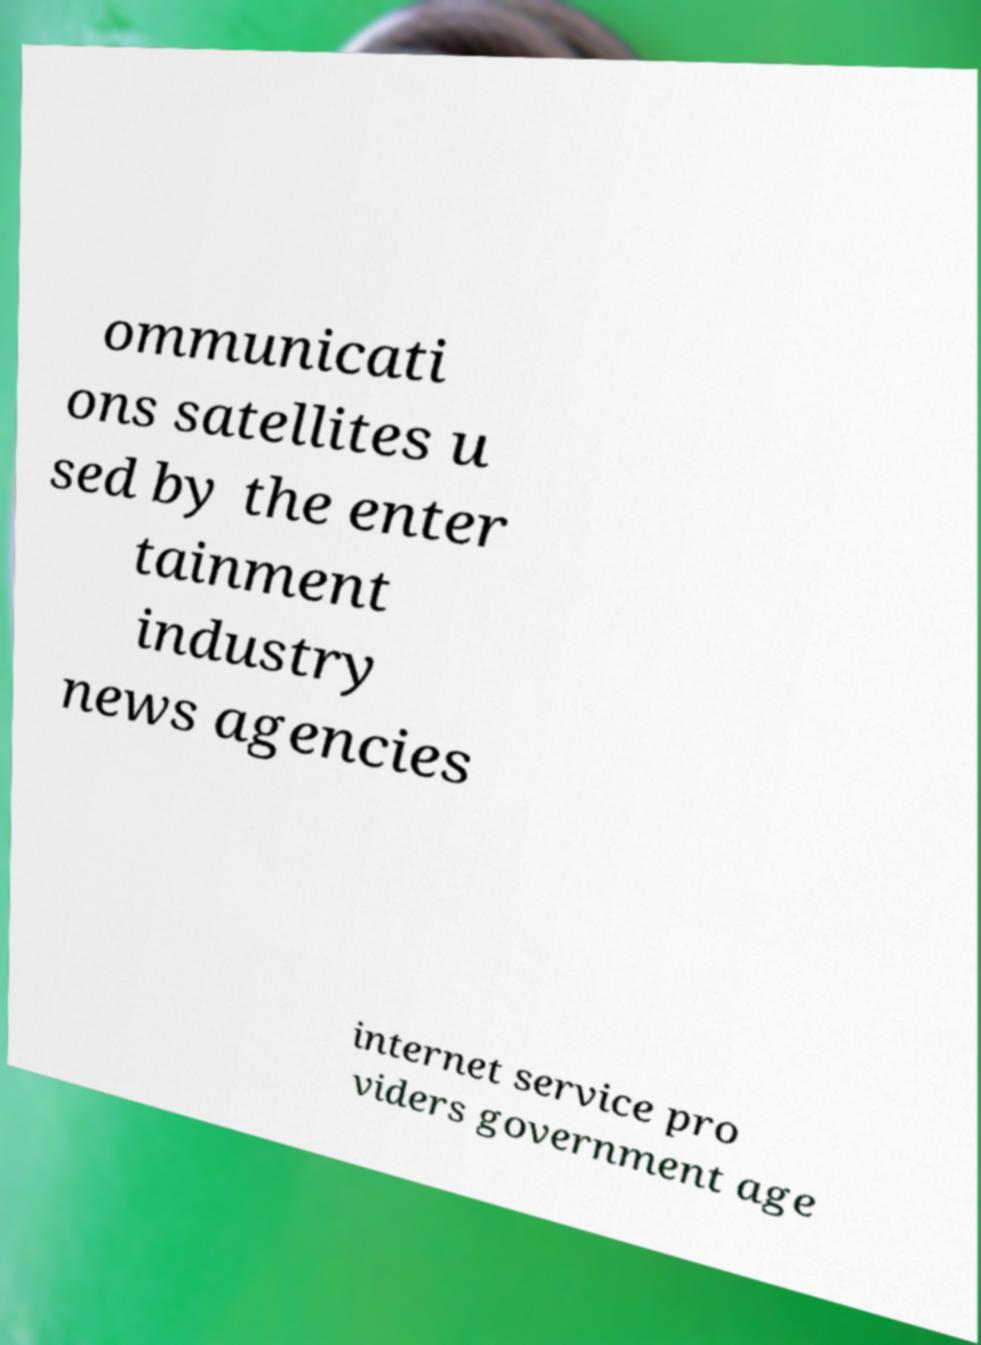Could you extract and type out the text from this image? ommunicati ons satellites u sed by the enter tainment industry news agencies internet service pro viders government age 